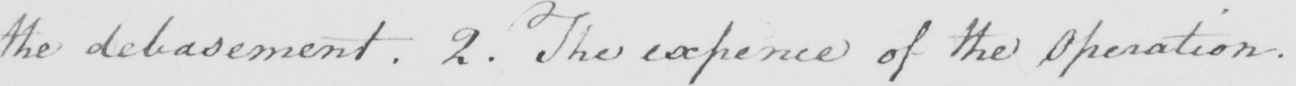Can you read and transcribe this handwriting? the debasement . 2 . The expence of the Operation . 